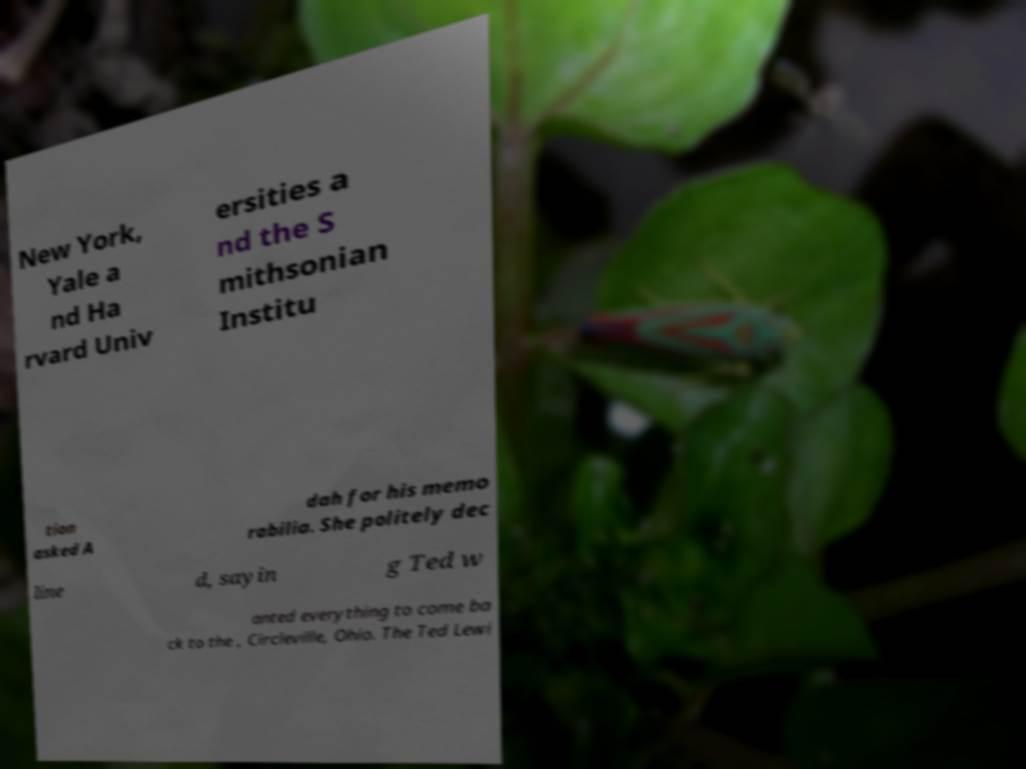What messages or text are displayed in this image? I need them in a readable, typed format. New York, Yale a nd Ha rvard Univ ersities a nd the S mithsonian Institu tion asked A dah for his memo rabilia. She politely dec line d, sayin g Ted w anted everything to come ba ck to the , Circleville, Ohio. The Ted Lewi 